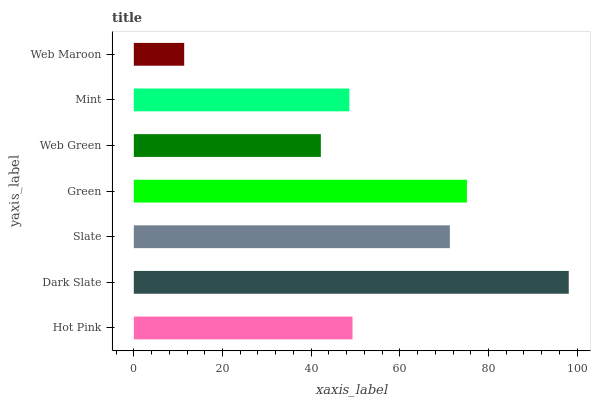Is Web Maroon the minimum?
Answer yes or no. Yes. Is Dark Slate the maximum?
Answer yes or no. Yes. Is Slate the minimum?
Answer yes or no. No. Is Slate the maximum?
Answer yes or no. No. Is Dark Slate greater than Slate?
Answer yes or no. Yes. Is Slate less than Dark Slate?
Answer yes or no. Yes. Is Slate greater than Dark Slate?
Answer yes or no. No. Is Dark Slate less than Slate?
Answer yes or no. No. Is Hot Pink the high median?
Answer yes or no. Yes. Is Hot Pink the low median?
Answer yes or no. Yes. Is Slate the high median?
Answer yes or no. No. Is Slate the low median?
Answer yes or no. No. 